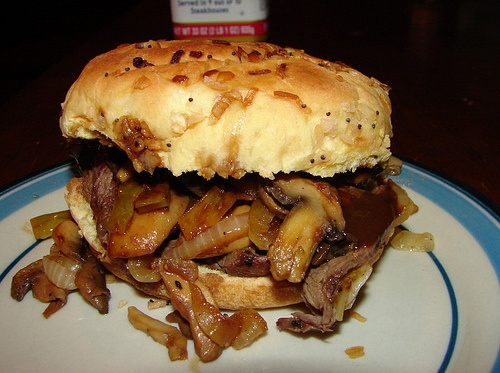Describe the objects in this image and their specific colors. I can see dining table in black, darkgray, olive, and maroon tones and sandwich in black, brown, maroon, and tan tones in this image. 